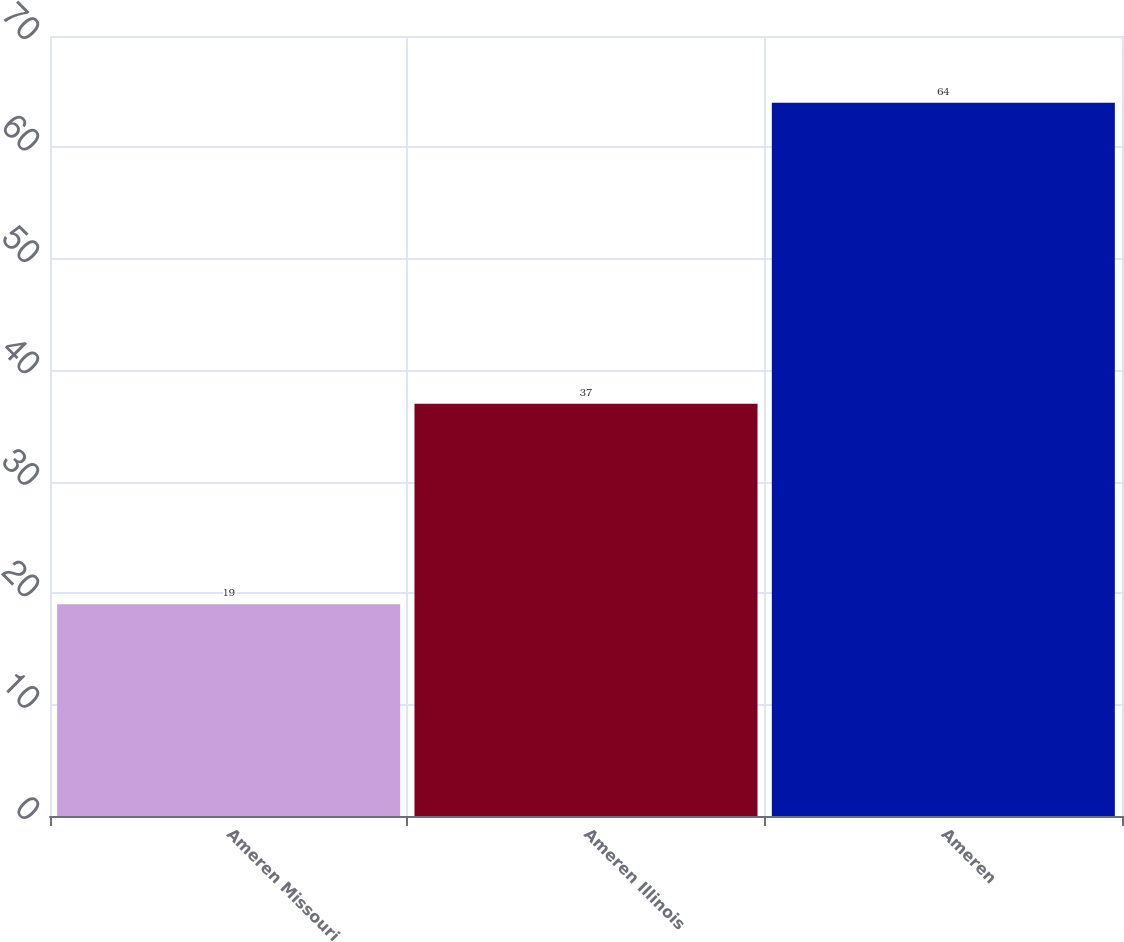<chart> <loc_0><loc_0><loc_500><loc_500><bar_chart><fcel>Ameren Missouri<fcel>Ameren Illinois<fcel>Ameren<nl><fcel>19<fcel>37<fcel>64<nl></chart> 